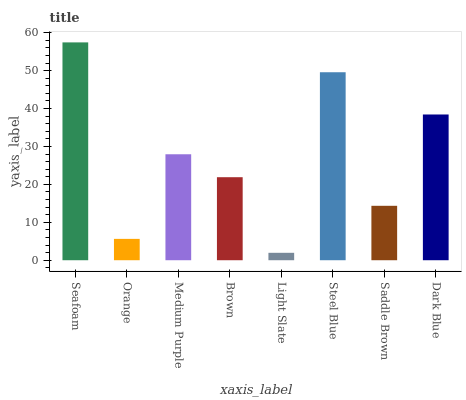Is Orange the minimum?
Answer yes or no. No. Is Orange the maximum?
Answer yes or no. No. Is Seafoam greater than Orange?
Answer yes or no. Yes. Is Orange less than Seafoam?
Answer yes or no. Yes. Is Orange greater than Seafoam?
Answer yes or no. No. Is Seafoam less than Orange?
Answer yes or no. No. Is Medium Purple the high median?
Answer yes or no. Yes. Is Brown the low median?
Answer yes or no. Yes. Is Steel Blue the high median?
Answer yes or no. No. Is Saddle Brown the low median?
Answer yes or no. No. 